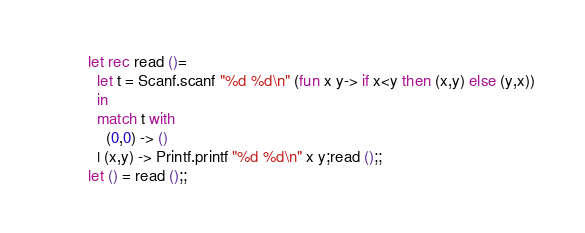<code> <loc_0><loc_0><loc_500><loc_500><_OCaml_>let rec read ()=
  let t = Scanf.scanf "%d %d\n" (fun x y-> if x<y then (x,y) else (y,x))
  in
  match t with
    (0,0) -> ()
  | (x,y) -> Printf.printf "%d %d\n" x y;read ();;
let () = read ();;</code> 